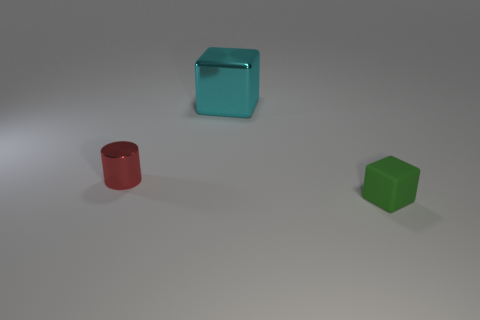Do the large cyan thing and the small green object have the same material?
Your answer should be very brief. No. How many cyan things are in front of the red shiny thing?
Offer a terse response. 0. There is a object that is both to the left of the matte block and to the right of the red cylinder; what is its material?
Offer a very short reply. Metal. How many spheres are large gray things or large cyan objects?
Ensure brevity in your answer.  0. There is a small green thing that is the same shape as the big metallic thing; what is it made of?
Your response must be concise. Rubber. The other object that is made of the same material as the big thing is what size?
Keep it short and to the point. Small. Does the small thing that is to the left of the green matte block have the same shape as the shiny object right of the small red shiny cylinder?
Offer a very short reply. No. There is a small cylinder that is the same material as the cyan cube; what color is it?
Ensure brevity in your answer.  Red. Do the block behind the tiny green object and the red metallic cylinder that is left of the cyan object have the same size?
Provide a short and direct response. No. What shape is the object that is to the right of the cylinder and in front of the big object?
Give a very brief answer. Cube. 